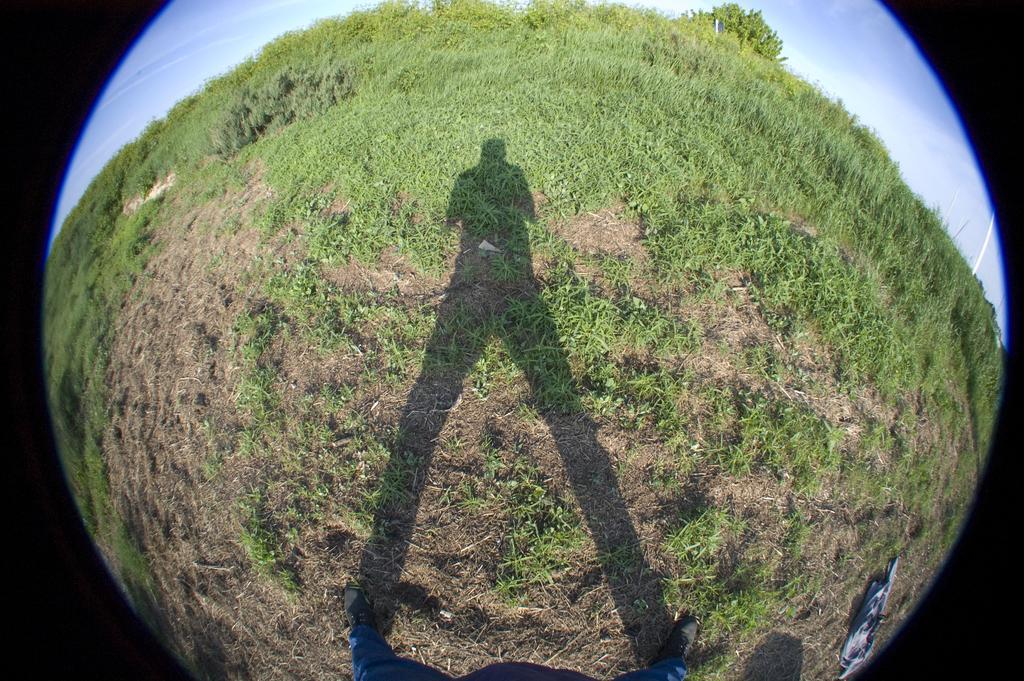Please provide a concise description of this image. This is a convex image, in this we can see a shadow of a person, grass and sky. 